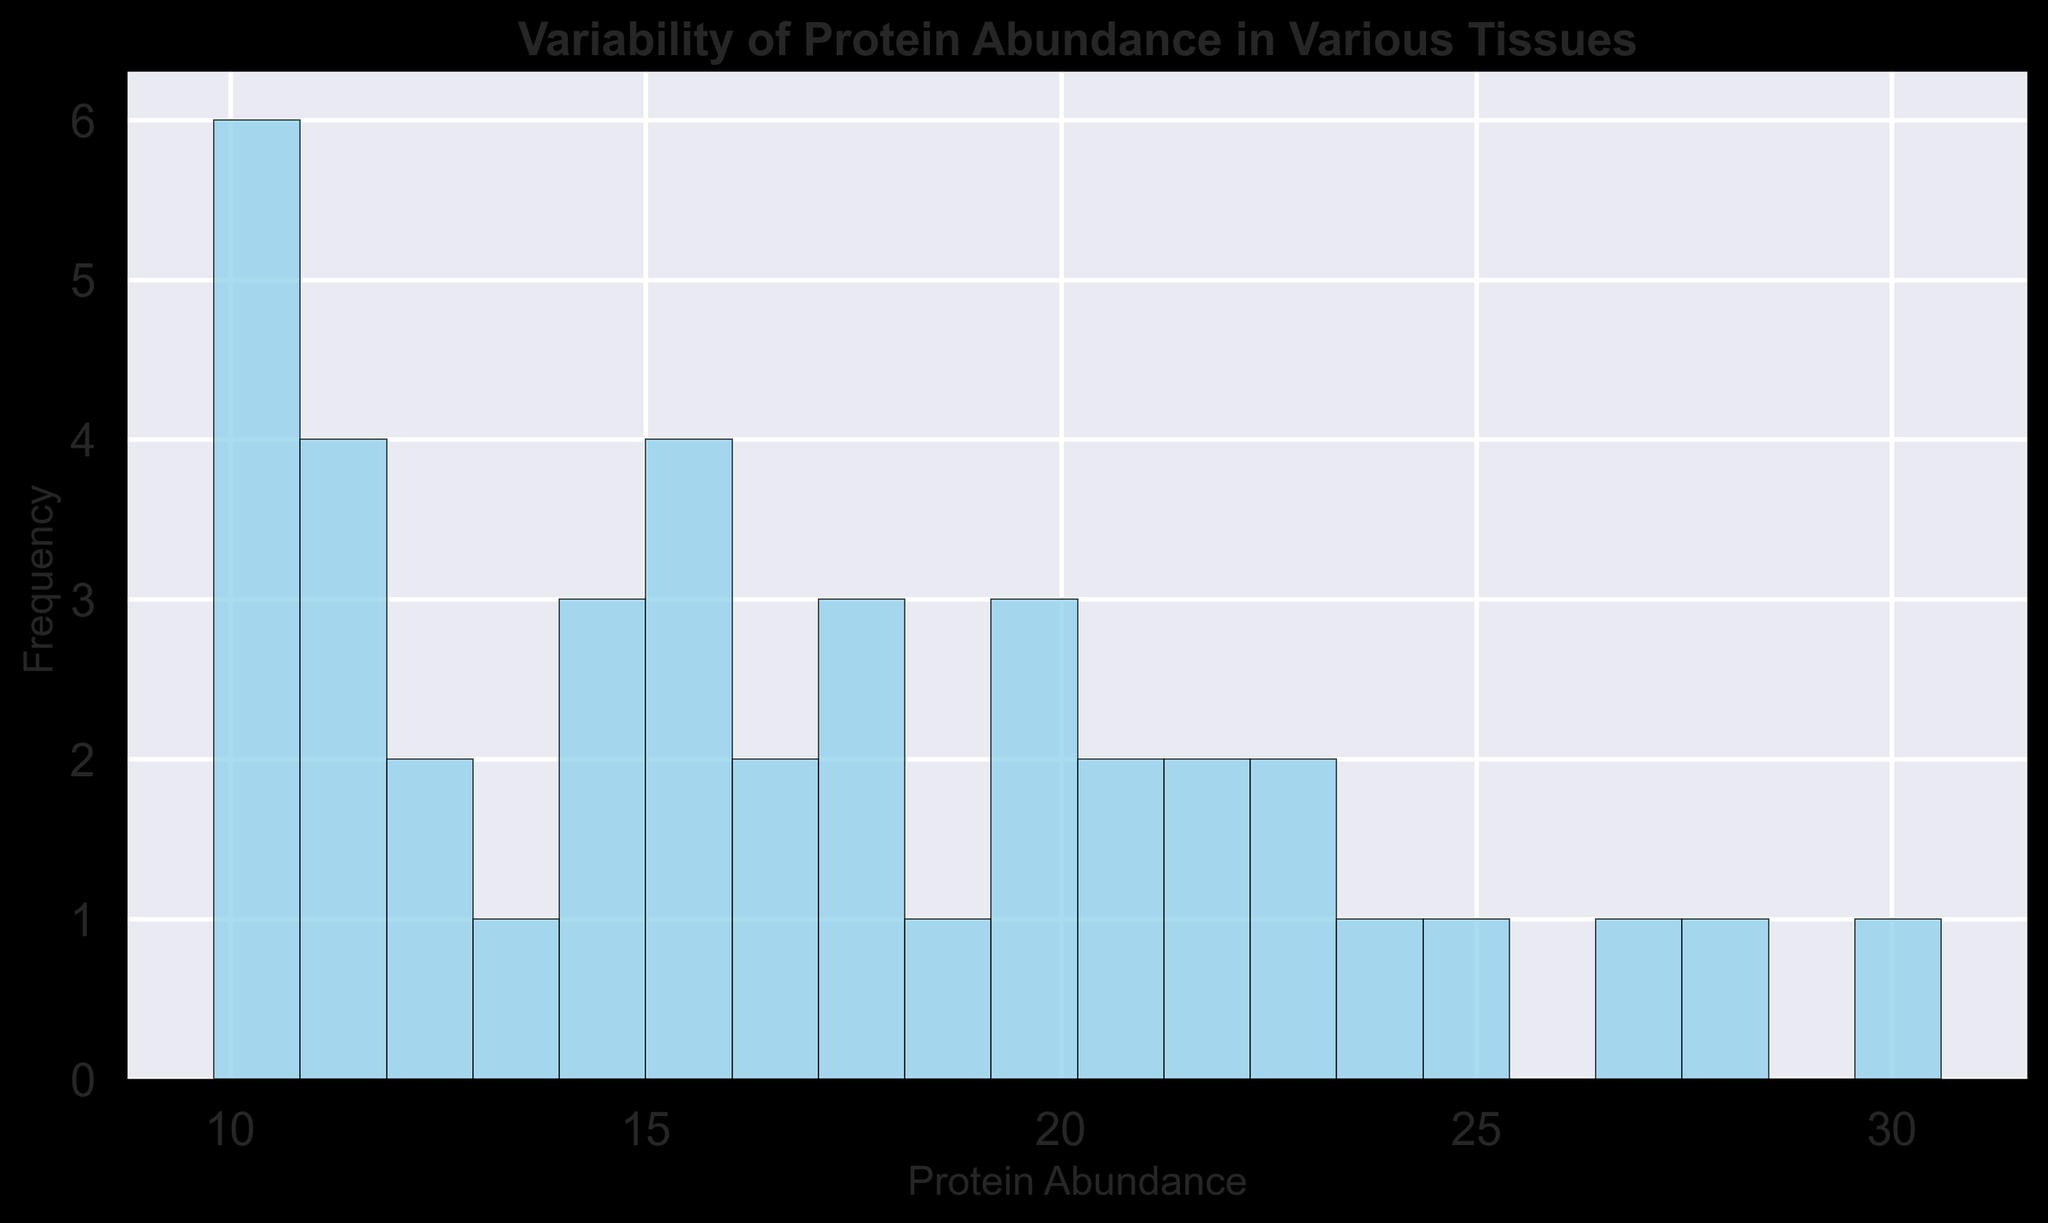What is the range of protein abundance values depicted in the histogram? To determine the range, find the minimum and maximum values shown in the histogram. The x-axis (Protein Abundance) will display these minimum and maximum values. Locate the lowest and highest bin edges to establish the range.
Answer: 9.8 to 30.6 Which tissue shows the highest protein abundance value? Considering the histogram aggregates data from all tissues, identify the highest bin to find the maximum value. Then, refer to the initial data to find the corresponding tissue with this maximum value. The highest abundance value is 30.6, which belongs to Liver.
Answer: Liver How many bins have frequencies greater than 4? Count the number of bins (bars in the histogram) with a height (frequency) greater than 4. Carefully examine the vertical (frequency) values to tally the count.
Answer: 3 What can you infer about the distribution of protein abundance across tissues based on the histogram shape? Analyzing the overall shape of the histogram can give insights into the distribution. Notice whether the distribution is symmetric, skewed, or has any clusters. For instance, if there's a right (positive) skew, more tissues have lower protein abundances, and vice versa for a left (negative) skew.
Answer: Positively skewed What is the most densely populated protein abundance bin? Identify the bin with the highest frequency by looking at the tallest bar in the histogram. The x-axis shows the range for each bin, so note down the range corresponding to the tallest bar.
Answer: 12.0 - 14.0 Which protein shows the highest variability in abundance across different tissues? Although the histogram doesn't directly show individual protein variability, one way to infer this is by identifying if any bins are exceptionally wide-ranging. However, this analysis requires data examination, making it more suitable for further analysis beyond the histogram.
Answer: Requires further analysis How does the frequency of the 10-12 abundance bin compare to the 20-22 bin? Find the heights (frequencies) of the bins corresponding to the 10-12 and 20-22 ranges on the x-axis and compare these values.
Answer: The 10-12 bin has a higher frequency On average, is protein abundance higher in the 9-15 range or the 21-27 range? Calculate the mean frequency for the bins in the 9-15 range and compare it with the mean frequency for bins in the 21-27 range to determine which has a higher average abundance.
Answer: Lower in the 9-15 range What is the total frequency of protein abundance values above 20? Sum the frequencies of all bins corresponding to protein abundance values greater than 20, as indicated on the x-axis.
Answer: 10 